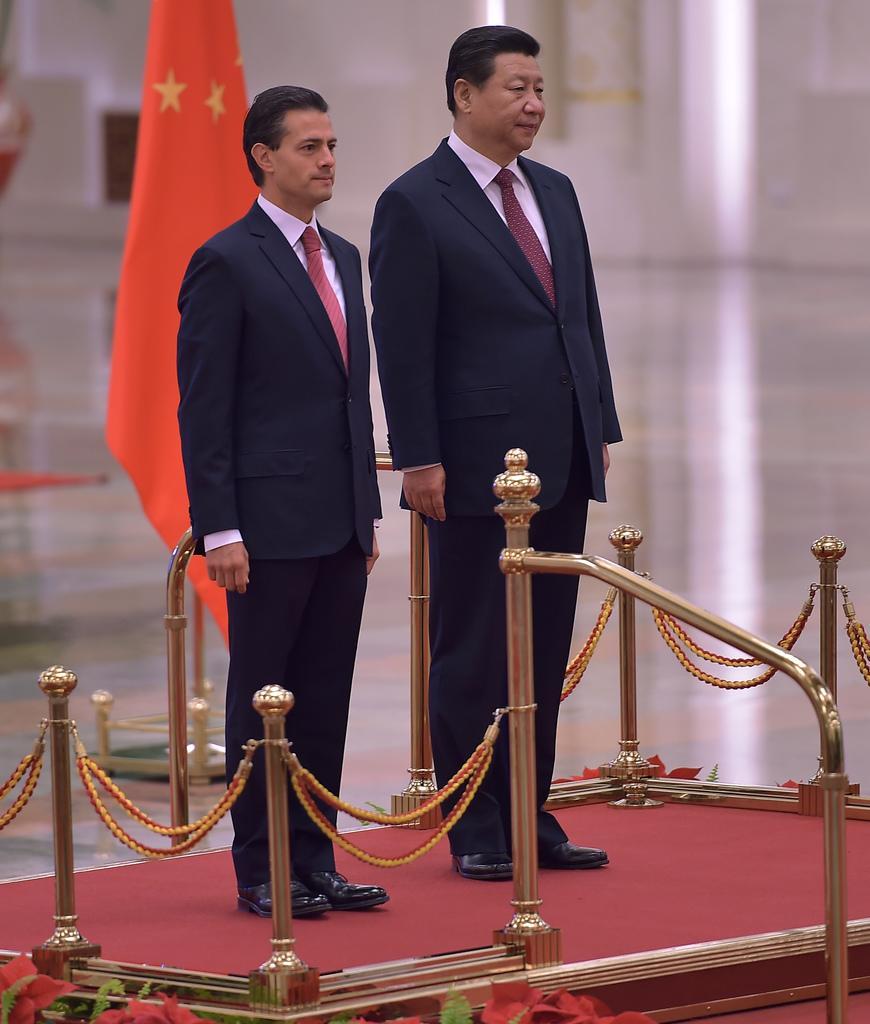Could you give a brief overview of what you see in this image? Bottom of the image there is a fencing. Behind the fencing two persons are standing. Behind them there is a pole and flag. 